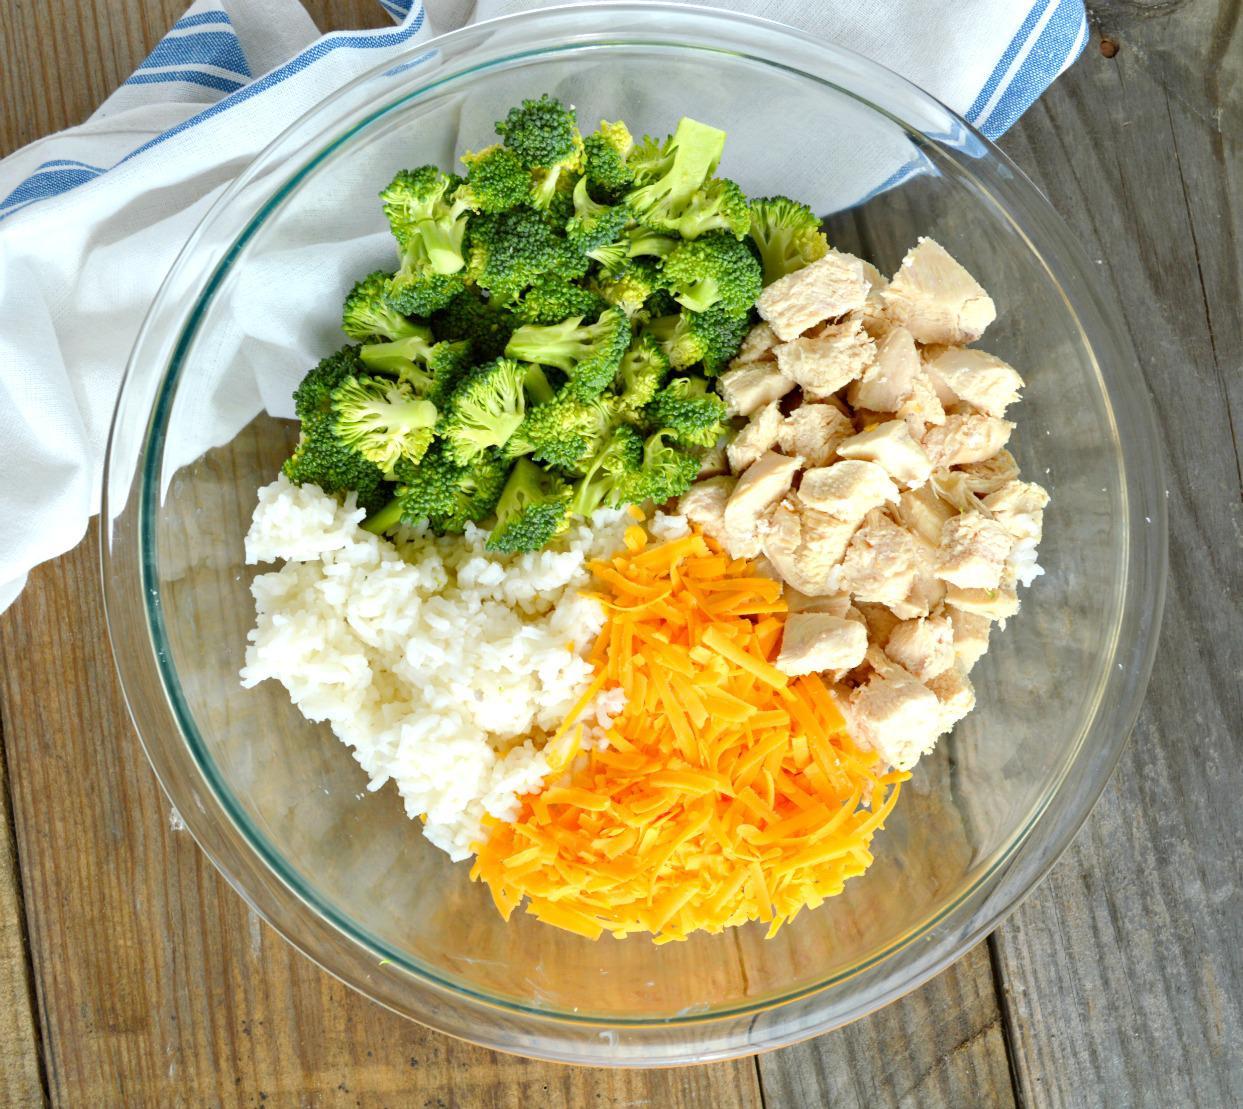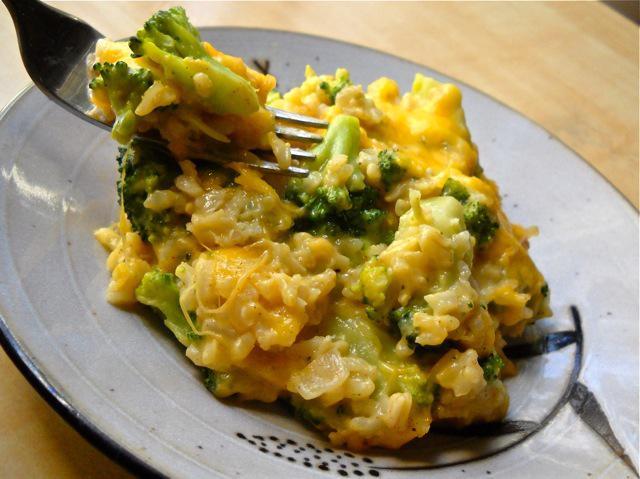The first image is the image on the left, the second image is the image on the right. Considering the images on both sides, is "In one of the images there is a plate of broccoli casserole with a fork." valid? Answer yes or no. Yes. 